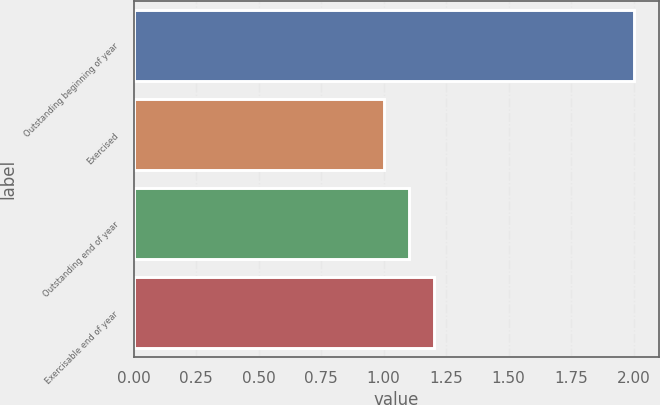Convert chart. <chart><loc_0><loc_0><loc_500><loc_500><bar_chart><fcel>Outstanding beginning of year<fcel>Exercised<fcel>Outstanding end of year<fcel>Exercisable end of year<nl><fcel>2<fcel>1<fcel>1.1<fcel>1.2<nl></chart> 